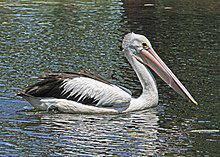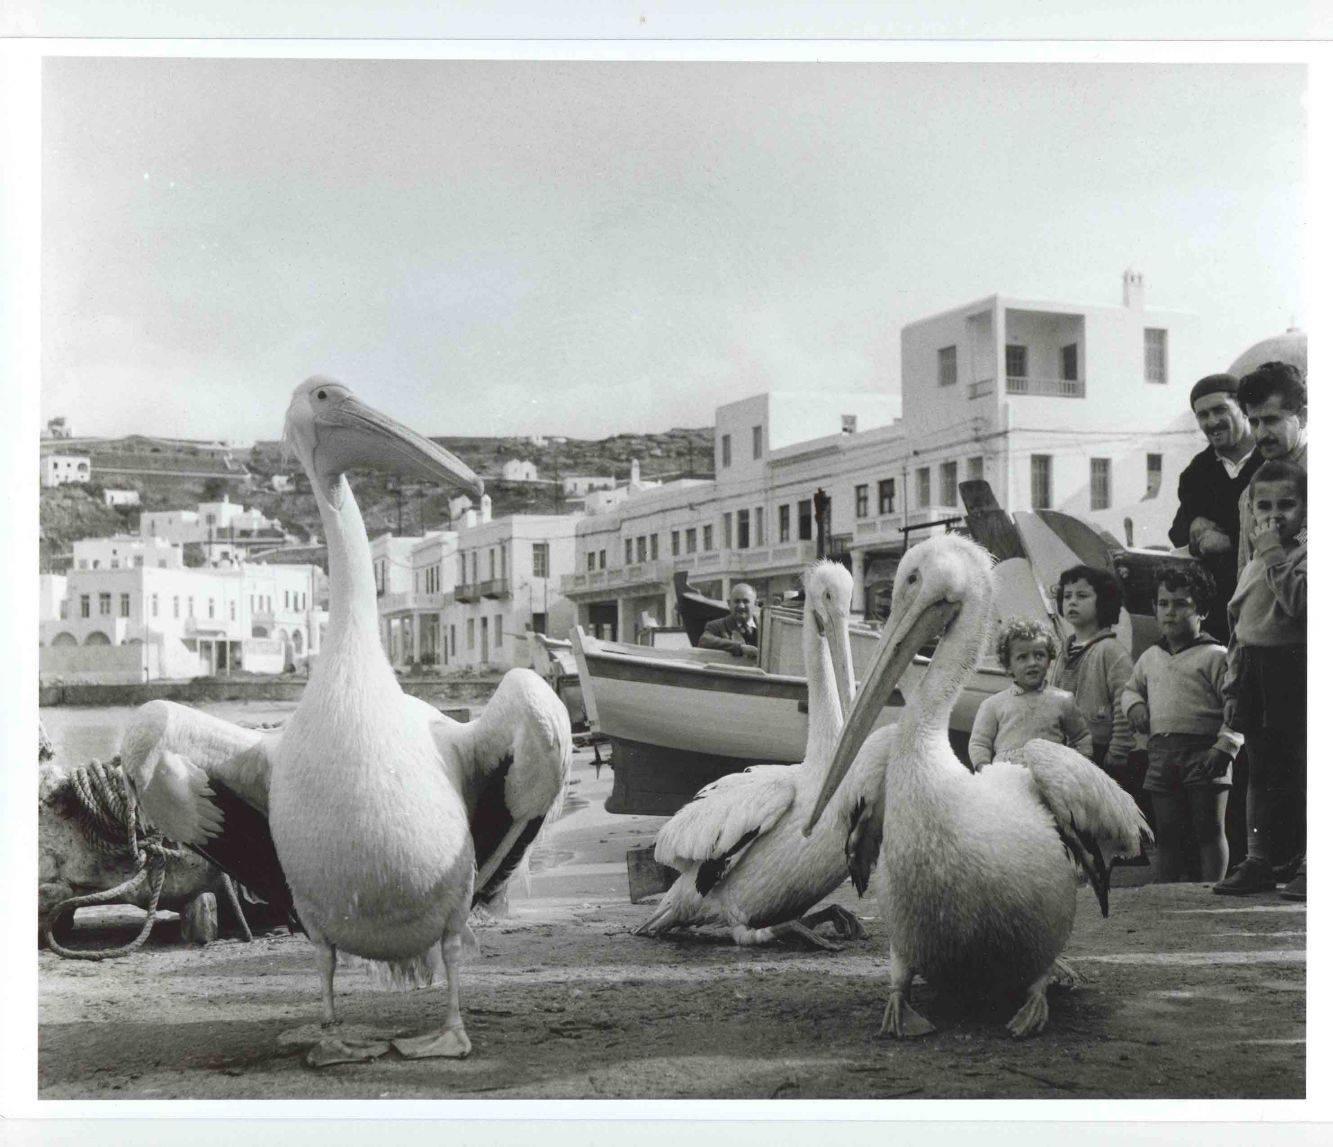The first image is the image on the left, the second image is the image on the right. Examine the images to the left and right. Is the description "The left image shows one pelican floating on the water" accurate? Answer yes or no. Yes. The first image is the image on the left, the second image is the image on the right. Assess this claim about the two images: "Left image contains only one pelican, which is on water.". Correct or not? Answer yes or no. Yes. 